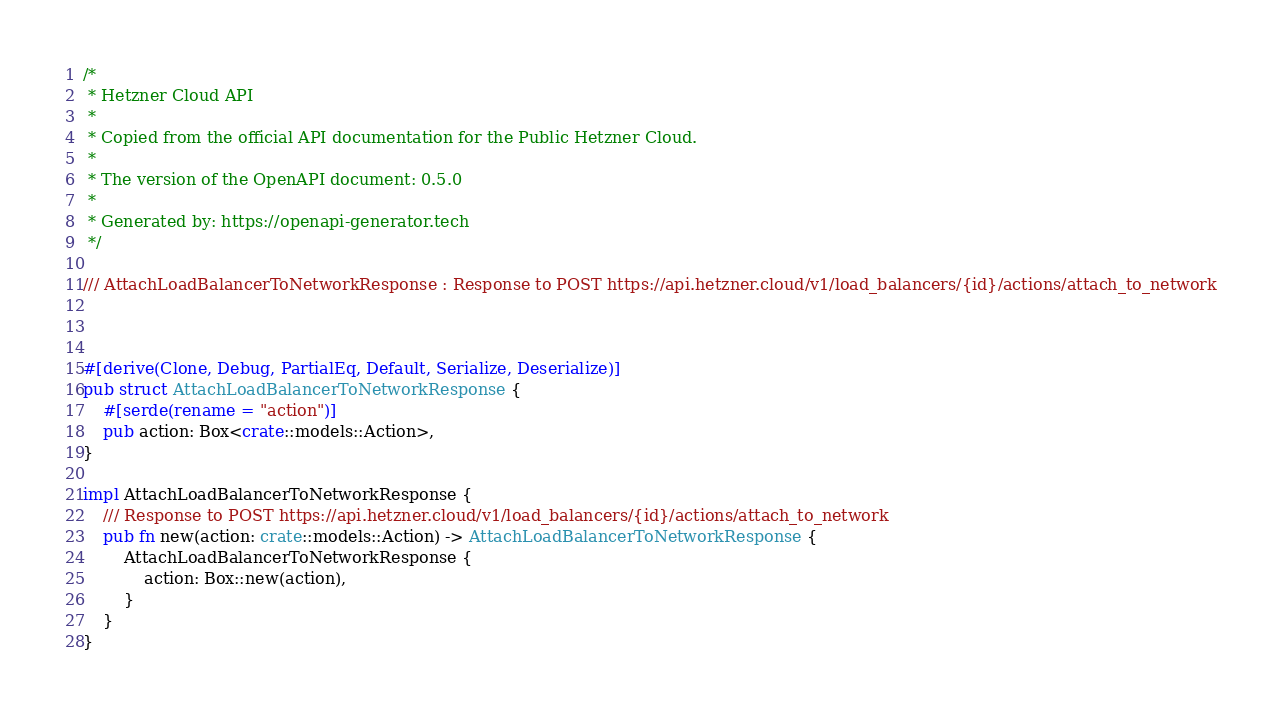Convert code to text. <code><loc_0><loc_0><loc_500><loc_500><_Rust_>/*
 * Hetzner Cloud API
 *
 * Copied from the official API documentation for the Public Hetzner Cloud.
 *
 * The version of the OpenAPI document: 0.5.0
 * 
 * Generated by: https://openapi-generator.tech
 */

/// AttachLoadBalancerToNetworkResponse : Response to POST https://api.hetzner.cloud/v1/load_balancers/{id}/actions/attach_to_network



#[derive(Clone, Debug, PartialEq, Default, Serialize, Deserialize)]
pub struct AttachLoadBalancerToNetworkResponse {
    #[serde(rename = "action")]
    pub action: Box<crate::models::Action>,
}

impl AttachLoadBalancerToNetworkResponse {
    /// Response to POST https://api.hetzner.cloud/v1/load_balancers/{id}/actions/attach_to_network
    pub fn new(action: crate::models::Action) -> AttachLoadBalancerToNetworkResponse {
        AttachLoadBalancerToNetworkResponse {
            action: Box::new(action),
        }
    }
}


</code> 